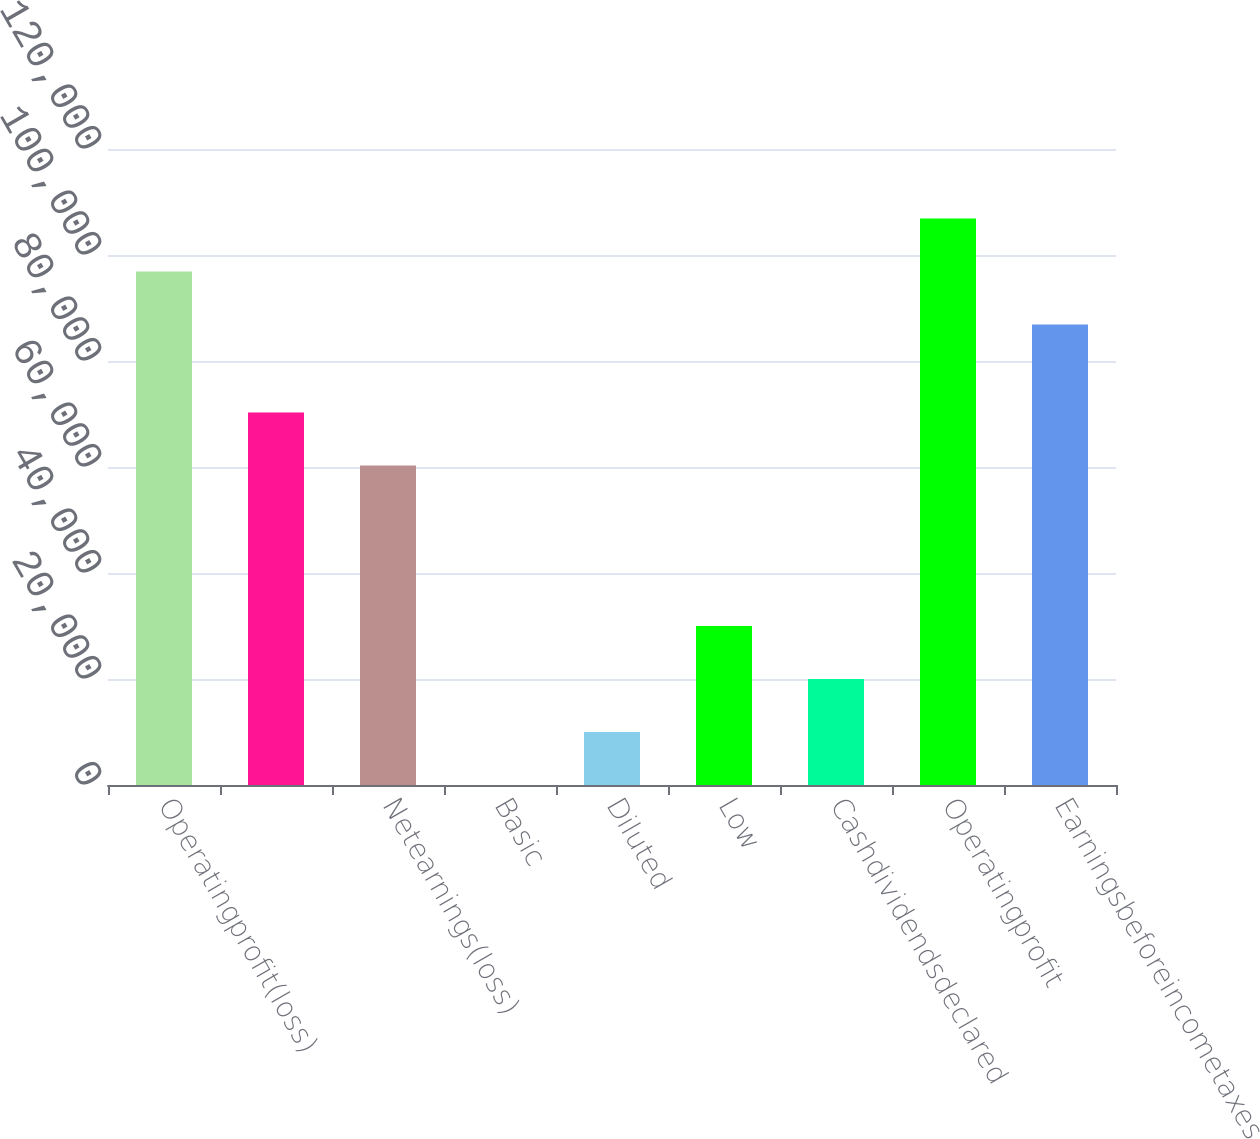<chart> <loc_0><loc_0><loc_500><loc_500><bar_chart><fcel>Operatingprofit(loss)<fcel>Unnamed: 1<fcel>Netearnings(loss)<fcel>Basic<fcel>Diluted<fcel>Low<fcel>Cashdividendsdeclared<fcel>Operatingprofit<fcel>Earningsbeforeincometaxes<nl><fcel>96884.4<fcel>70297.4<fcel>60299<fcel>0.48<fcel>9998.83<fcel>29995.5<fcel>19997.2<fcel>106883<fcel>86886<nl></chart> 